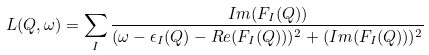Convert formula to latex. <formula><loc_0><loc_0><loc_500><loc_500>L ( { Q } , \omega ) = \sum _ { I } \frac { I m ( F _ { I } ( { Q } ) ) } { ( \omega - \epsilon _ { I } ( { Q } ) - R e ( F _ { I } ( { Q } ) ) ) ^ { 2 } + ( I m ( F _ { I } ( { Q } ) ) ) ^ { 2 } }</formula> 